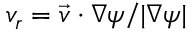<formula> <loc_0><loc_0><loc_500><loc_500>v _ { r } = \vec { v } \cdot \nabla \psi / | \nabla \psi |</formula> 